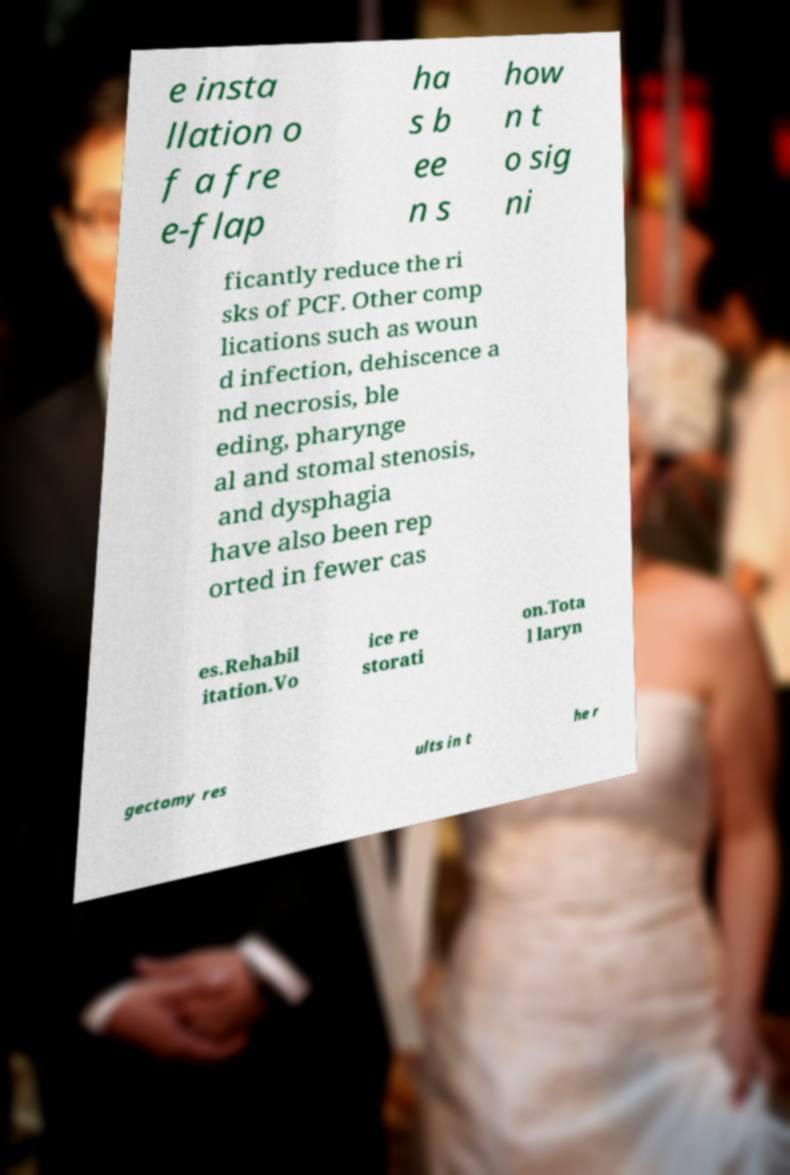I need the written content from this picture converted into text. Can you do that? e insta llation o f a fre e-flap ha s b ee n s how n t o sig ni ficantly reduce the ri sks of PCF. Other comp lications such as woun d infection, dehiscence a nd necrosis, ble eding, pharynge al and stomal stenosis, and dysphagia have also been rep orted in fewer cas es.Rehabil itation.Vo ice re storati on.Tota l laryn gectomy res ults in t he r 